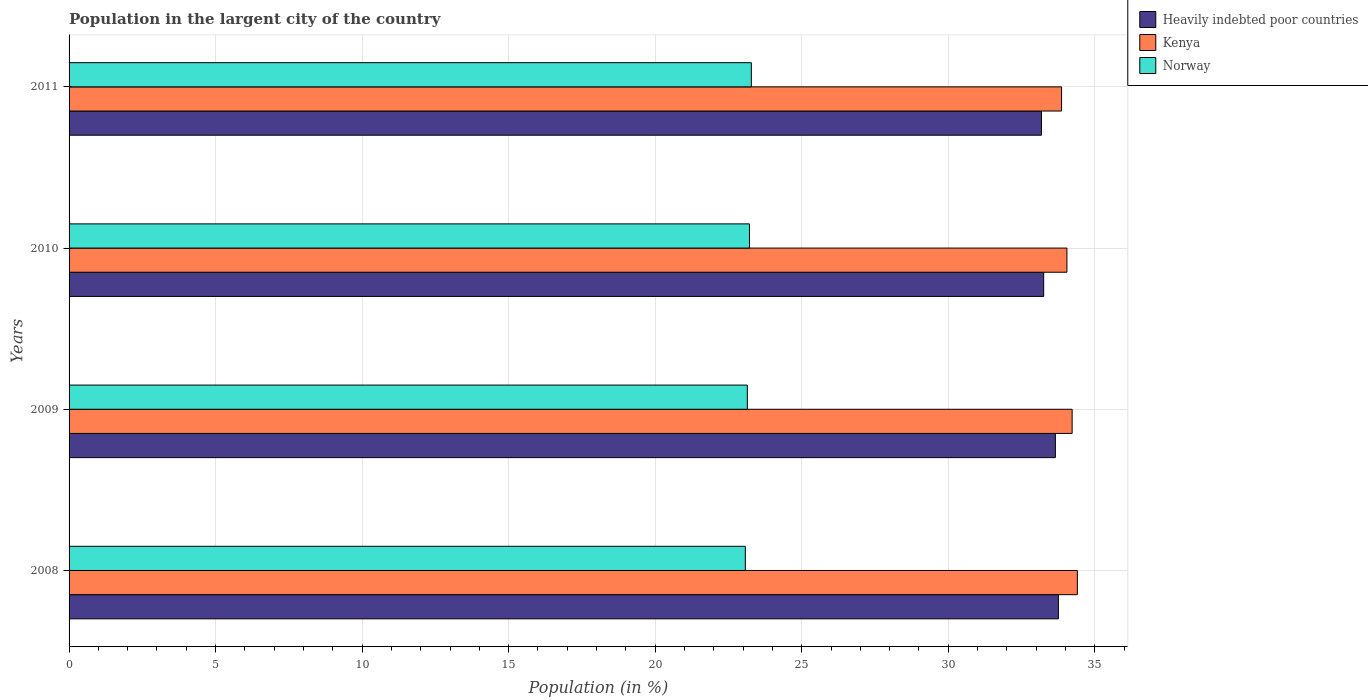How many groups of bars are there?
Your answer should be very brief. 4. Are the number of bars per tick equal to the number of legend labels?
Provide a short and direct response. Yes. How many bars are there on the 2nd tick from the bottom?
Your answer should be compact. 3. What is the label of the 1st group of bars from the top?
Offer a very short reply. 2011. What is the percentage of population in the largent city in Heavily indebted poor countries in 2010?
Keep it short and to the point. 33.26. Across all years, what is the maximum percentage of population in the largent city in Norway?
Provide a succinct answer. 23.28. Across all years, what is the minimum percentage of population in the largent city in Kenya?
Your answer should be compact. 33.87. What is the total percentage of population in the largent city in Kenya in the graph?
Offer a very short reply. 136.55. What is the difference between the percentage of population in the largent city in Norway in 2008 and that in 2010?
Ensure brevity in your answer.  -0.14. What is the difference between the percentage of population in the largent city in Kenya in 2009 and the percentage of population in the largent city in Heavily indebted poor countries in 2008?
Your answer should be very brief. 0.47. What is the average percentage of population in the largent city in Heavily indebted poor countries per year?
Offer a terse response. 33.46. In the year 2010, what is the difference between the percentage of population in the largent city in Kenya and percentage of population in the largent city in Norway?
Your answer should be compact. 10.83. What is the ratio of the percentage of population in the largent city in Norway in 2009 to that in 2011?
Provide a succinct answer. 0.99. What is the difference between the highest and the second highest percentage of population in the largent city in Heavily indebted poor countries?
Offer a terse response. 0.1. What is the difference between the highest and the lowest percentage of population in the largent city in Kenya?
Ensure brevity in your answer.  0.54. In how many years, is the percentage of population in the largent city in Kenya greater than the average percentage of population in the largent city in Kenya taken over all years?
Ensure brevity in your answer.  2. Is the sum of the percentage of population in the largent city in Kenya in 2008 and 2009 greater than the maximum percentage of population in the largent city in Heavily indebted poor countries across all years?
Your answer should be compact. Yes. What does the 2nd bar from the top in 2009 represents?
Ensure brevity in your answer.  Kenya. What does the 2nd bar from the bottom in 2011 represents?
Offer a terse response. Kenya. How many years are there in the graph?
Your answer should be compact. 4. What is the difference between two consecutive major ticks on the X-axis?
Your answer should be compact. 5. Are the values on the major ticks of X-axis written in scientific E-notation?
Give a very brief answer. No. Does the graph contain any zero values?
Your answer should be very brief. No. Does the graph contain grids?
Give a very brief answer. Yes. Where does the legend appear in the graph?
Ensure brevity in your answer.  Top right. How are the legend labels stacked?
Your response must be concise. Vertical. What is the title of the graph?
Offer a terse response. Population in the largent city of the country. Does "Austria" appear as one of the legend labels in the graph?
Offer a terse response. No. What is the Population (in %) of Heavily indebted poor countries in 2008?
Your answer should be compact. 33.76. What is the Population (in %) of Kenya in 2008?
Make the answer very short. 34.4. What is the Population (in %) of Norway in 2008?
Give a very brief answer. 23.08. What is the Population (in %) in Heavily indebted poor countries in 2009?
Give a very brief answer. 33.65. What is the Population (in %) in Kenya in 2009?
Offer a terse response. 34.23. What is the Population (in %) in Norway in 2009?
Your answer should be very brief. 23.14. What is the Population (in %) of Heavily indebted poor countries in 2010?
Keep it short and to the point. 33.26. What is the Population (in %) of Kenya in 2010?
Offer a terse response. 34.05. What is the Population (in %) in Norway in 2010?
Give a very brief answer. 23.22. What is the Population (in %) of Heavily indebted poor countries in 2011?
Your answer should be compact. 33.18. What is the Population (in %) in Kenya in 2011?
Give a very brief answer. 33.87. What is the Population (in %) in Norway in 2011?
Your answer should be very brief. 23.28. Across all years, what is the maximum Population (in %) of Heavily indebted poor countries?
Make the answer very short. 33.76. Across all years, what is the maximum Population (in %) of Kenya?
Keep it short and to the point. 34.4. Across all years, what is the maximum Population (in %) in Norway?
Offer a very short reply. 23.28. Across all years, what is the minimum Population (in %) in Heavily indebted poor countries?
Make the answer very short. 33.18. Across all years, what is the minimum Population (in %) of Kenya?
Offer a terse response. 33.87. Across all years, what is the minimum Population (in %) in Norway?
Your response must be concise. 23.08. What is the total Population (in %) of Heavily indebted poor countries in the graph?
Offer a terse response. 133.85. What is the total Population (in %) in Kenya in the graph?
Offer a terse response. 136.55. What is the total Population (in %) of Norway in the graph?
Your response must be concise. 92.72. What is the difference between the Population (in %) of Heavily indebted poor countries in 2008 and that in 2009?
Provide a succinct answer. 0.1. What is the difference between the Population (in %) in Kenya in 2008 and that in 2009?
Your answer should be compact. 0.18. What is the difference between the Population (in %) of Norway in 2008 and that in 2009?
Keep it short and to the point. -0.07. What is the difference between the Population (in %) of Heavily indebted poor countries in 2008 and that in 2010?
Your answer should be compact. 0.5. What is the difference between the Population (in %) in Kenya in 2008 and that in 2010?
Your response must be concise. 0.36. What is the difference between the Population (in %) in Norway in 2008 and that in 2010?
Provide a succinct answer. -0.14. What is the difference between the Population (in %) of Heavily indebted poor countries in 2008 and that in 2011?
Offer a terse response. 0.58. What is the difference between the Population (in %) of Kenya in 2008 and that in 2011?
Ensure brevity in your answer.  0.54. What is the difference between the Population (in %) in Norway in 2008 and that in 2011?
Provide a short and direct response. -0.21. What is the difference between the Population (in %) in Heavily indebted poor countries in 2009 and that in 2010?
Make the answer very short. 0.4. What is the difference between the Population (in %) of Kenya in 2009 and that in 2010?
Ensure brevity in your answer.  0.18. What is the difference between the Population (in %) of Norway in 2009 and that in 2010?
Provide a short and direct response. -0.07. What is the difference between the Population (in %) in Heavily indebted poor countries in 2009 and that in 2011?
Provide a succinct answer. 0.47. What is the difference between the Population (in %) of Kenya in 2009 and that in 2011?
Keep it short and to the point. 0.36. What is the difference between the Population (in %) of Norway in 2009 and that in 2011?
Make the answer very short. -0.14. What is the difference between the Population (in %) in Heavily indebted poor countries in 2010 and that in 2011?
Keep it short and to the point. 0.08. What is the difference between the Population (in %) in Kenya in 2010 and that in 2011?
Your answer should be very brief. 0.18. What is the difference between the Population (in %) of Norway in 2010 and that in 2011?
Make the answer very short. -0.06. What is the difference between the Population (in %) in Heavily indebted poor countries in 2008 and the Population (in %) in Kenya in 2009?
Keep it short and to the point. -0.47. What is the difference between the Population (in %) in Heavily indebted poor countries in 2008 and the Population (in %) in Norway in 2009?
Ensure brevity in your answer.  10.61. What is the difference between the Population (in %) of Kenya in 2008 and the Population (in %) of Norway in 2009?
Give a very brief answer. 11.26. What is the difference between the Population (in %) of Heavily indebted poor countries in 2008 and the Population (in %) of Kenya in 2010?
Offer a terse response. -0.29. What is the difference between the Population (in %) of Heavily indebted poor countries in 2008 and the Population (in %) of Norway in 2010?
Provide a short and direct response. 10.54. What is the difference between the Population (in %) of Kenya in 2008 and the Population (in %) of Norway in 2010?
Provide a succinct answer. 11.19. What is the difference between the Population (in %) in Heavily indebted poor countries in 2008 and the Population (in %) in Kenya in 2011?
Ensure brevity in your answer.  -0.11. What is the difference between the Population (in %) of Heavily indebted poor countries in 2008 and the Population (in %) of Norway in 2011?
Make the answer very short. 10.48. What is the difference between the Population (in %) of Kenya in 2008 and the Population (in %) of Norway in 2011?
Provide a succinct answer. 11.12. What is the difference between the Population (in %) in Heavily indebted poor countries in 2009 and the Population (in %) in Kenya in 2010?
Your response must be concise. -0.39. What is the difference between the Population (in %) in Heavily indebted poor countries in 2009 and the Population (in %) in Norway in 2010?
Ensure brevity in your answer.  10.44. What is the difference between the Population (in %) in Kenya in 2009 and the Population (in %) in Norway in 2010?
Provide a short and direct response. 11.01. What is the difference between the Population (in %) in Heavily indebted poor countries in 2009 and the Population (in %) in Kenya in 2011?
Give a very brief answer. -0.21. What is the difference between the Population (in %) in Heavily indebted poor countries in 2009 and the Population (in %) in Norway in 2011?
Your response must be concise. 10.37. What is the difference between the Population (in %) in Kenya in 2009 and the Population (in %) in Norway in 2011?
Provide a succinct answer. 10.95. What is the difference between the Population (in %) of Heavily indebted poor countries in 2010 and the Population (in %) of Kenya in 2011?
Provide a short and direct response. -0.61. What is the difference between the Population (in %) in Heavily indebted poor countries in 2010 and the Population (in %) in Norway in 2011?
Give a very brief answer. 9.98. What is the difference between the Population (in %) of Kenya in 2010 and the Population (in %) of Norway in 2011?
Give a very brief answer. 10.77. What is the average Population (in %) in Heavily indebted poor countries per year?
Give a very brief answer. 33.46. What is the average Population (in %) in Kenya per year?
Keep it short and to the point. 34.14. What is the average Population (in %) in Norway per year?
Your answer should be compact. 23.18. In the year 2008, what is the difference between the Population (in %) in Heavily indebted poor countries and Population (in %) in Kenya?
Offer a very short reply. -0.65. In the year 2008, what is the difference between the Population (in %) in Heavily indebted poor countries and Population (in %) in Norway?
Offer a very short reply. 10.68. In the year 2008, what is the difference between the Population (in %) in Kenya and Population (in %) in Norway?
Provide a succinct answer. 11.33. In the year 2009, what is the difference between the Population (in %) in Heavily indebted poor countries and Population (in %) in Kenya?
Offer a terse response. -0.57. In the year 2009, what is the difference between the Population (in %) of Heavily indebted poor countries and Population (in %) of Norway?
Provide a succinct answer. 10.51. In the year 2009, what is the difference between the Population (in %) in Kenya and Population (in %) in Norway?
Your answer should be very brief. 11.08. In the year 2010, what is the difference between the Population (in %) of Heavily indebted poor countries and Population (in %) of Kenya?
Provide a short and direct response. -0.79. In the year 2010, what is the difference between the Population (in %) of Heavily indebted poor countries and Population (in %) of Norway?
Give a very brief answer. 10.04. In the year 2010, what is the difference between the Population (in %) of Kenya and Population (in %) of Norway?
Provide a succinct answer. 10.83. In the year 2011, what is the difference between the Population (in %) in Heavily indebted poor countries and Population (in %) in Kenya?
Ensure brevity in your answer.  -0.69. In the year 2011, what is the difference between the Population (in %) of Heavily indebted poor countries and Population (in %) of Norway?
Ensure brevity in your answer.  9.9. In the year 2011, what is the difference between the Population (in %) in Kenya and Population (in %) in Norway?
Your answer should be compact. 10.59. What is the ratio of the Population (in %) of Heavily indebted poor countries in 2008 to that in 2009?
Keep it short and to the point. 1. What is the ratio of the Population (in %) of Norway in 2008 to that in 2009?
Ensure brevity in your answer.  1. What is the ratio of the Population (in %) of Heavily indebted poor countries in 2008 to that in 2010?
Your answer should be compact. 1.02. What is the ratio of the Population (in %) of Kenya in 2008 to that in 2010?
Offer a terse response. 1.01. What is the ratio of the Population (in %) of Heavily indebted poor countries in 2008 to that in 2011?
Make the answer very short. 1.02. What is the ratio of the Population (in %) in Kenya in 2008 to that in 2011?
Give a very brief answer. 1.02. What is the ratio of the Population (in %) of Kenya in 2009 to that in 2010?
Your answer should be very brief. 1.01. What is the ratio of the Population (in %) of Norway in 2009 to that in 2010?
Make the answer very short. 1. What is the ratio of the Population (in %) in Heavily indebted poor countries in 2009 to that in 2011?
Ensure brevity in your answer.  1.01. What is the ratio of the Population (in %) of Kenya in 2009 to that in 2011?
Offer a very short reply. 1.01. What is the ratio of the Population (in %) in Norway in 2009 to that in 2011?
Your answer should be very brief. 0.99. What is the ratio of the Population (in %) in Kenya in 2010 to that in 2011?
Ensure brevity in your answer.  1.01. What is the ratio of the Population (in %) in Norway in 2010 to that in 2011?
Offer a terse response. 1. What is the difference between the highest and the second highest Population (in %) of Heavily indebted poor countries?
Ensure brevity in your answer.  0.1. What is the difference between the highest and the second highest Population (in %) of Kenya?
Offer a very short reply. 0.18. What is the difference between the highest and the second highest Population (in %) of Norway?
Provide a succinct answer. 0.06. What is the difference between the highest and the lowest Population (in %) of Heavily indebted poor countries?
Keep it short and to the point. 0.58. What is the difference between the highest and the lowest Population (in %) in Kenya?
Your answer should be very brief. 0.54. What is the difference between the highest and the lowest Population (in %) of Norway?
Provide a short and direct response. 0.21. 